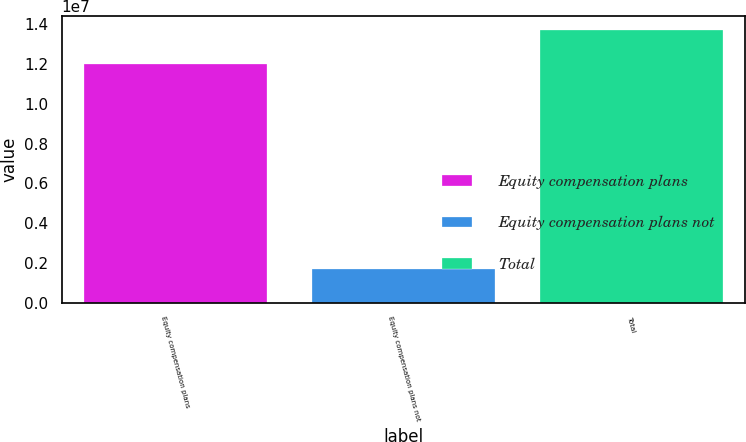Convert chart. <chart><loc_0><loc_0><loc_500><loc_500><bar_chart><fcel>Equity compensation plans<fcel>Equity compensation plans not<fcel>Total<nl><fcel>1.20101e+07<fcel>1.71505e+06<fcel>1.37251e+07<nl></chart> 